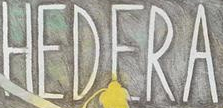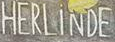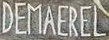What words are shown in these images in order, separated by a semicolon? HEDERA; HERLiNDE; DEMAEREL 